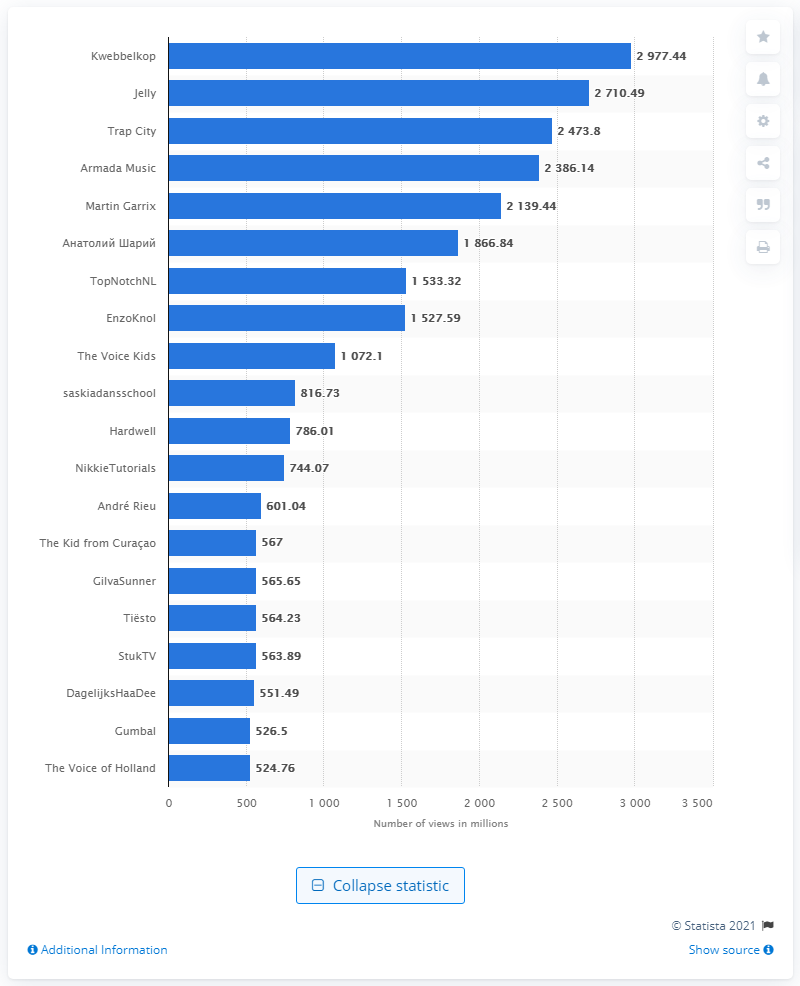Highlight a few significant elements in this photo. Armada Music, Trap City, and Jelly are popular game streamers in the Netherlands. Kwebbelkop, a popular game streamer from the Netherlands, had the most views of all Dutch video producers. 